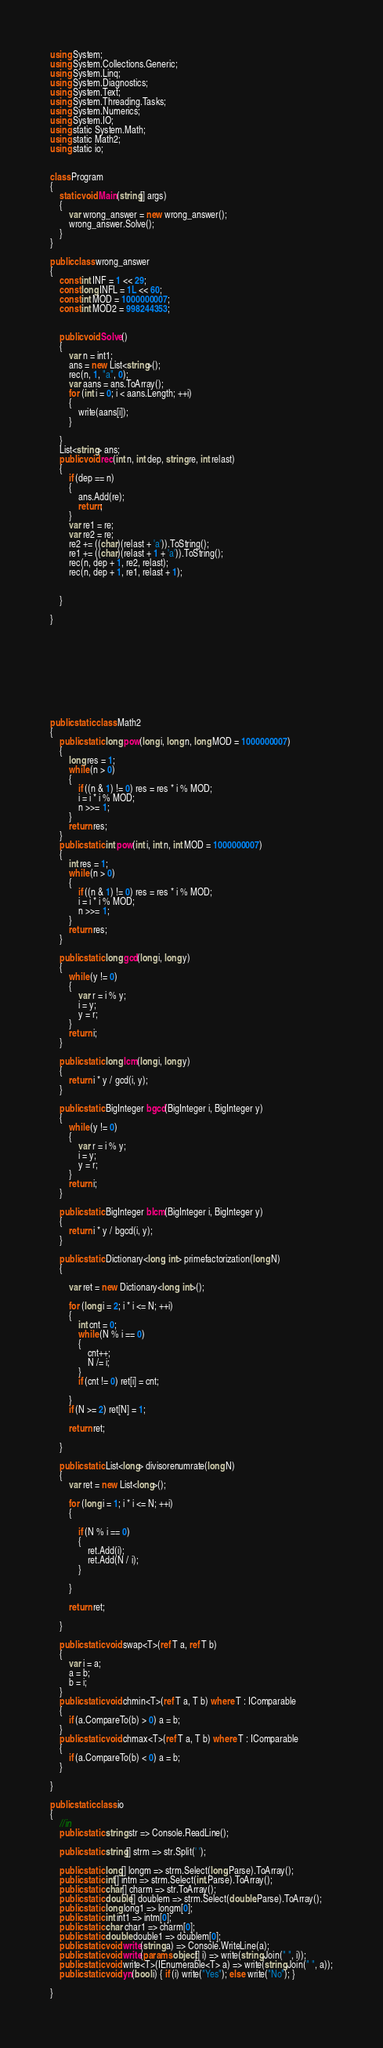Convert code to text. <code><loc_0><loc_0><loc_500><loc_500><_C#_>using System;
using System.Collections.Generic;
using System.Linq;
using System.Diagnostics;
using System.Text;
using System.Threading.Tasks;
using System.Numerics;
using System.IO;
using static System.Math;
using static Math2;
using static io;


class Program
{
    static void Main(string[] args)
    {
        var wrong_answer = new wrong_answer();
        wrong_answer.Solve();
    }
}

public class wrong_answer
{
    const int INF = 1 << 29;
    const long INFL = 1L << 60;
    const int MOD = 1000000007;
    const int MOD2 = 998244353;


    public void Solve()
    {
        var n = int1;
        ans = new List<string>();
        rec(n, 1, "a", 0);
        var aans = ans.ToArray();
        for (int i = 0; i < aans.Length; ++i)
        {
            write(aans[i]);
        }

    }
    List<string> ans;
    public void rec(int n, int dep, string re, int relast)
    {
        if (dep == n)
        {
            ans.Add(re);
            return;
        }
        var re1 = re;
        var re2 = re;
        re2 += ((char)(relast + 'a')).ToString();
        re1 += ((char)(relast + 1 + 'a')).ToString();
        rec(n, dep + 1, re2, relast);
        rec(n, dep + 1, re1, relast + 1);


    }

}










public static class Math2
{
    public static long pow(long i, long n, long MOD = 1000000007)
    {
        long res = 1;
        while (n > 0)
        {
            if ((n & 1) != 0) res = res * i % MOD;
            i = i * i % MOD;
            n >>= 1;
        }
        return res;
    }
    public static int pow(int i, int n, int MOD = 1000000007)
    {
        int res = 1;
        while (n > 0)
        {
            if ((n & 1) != 0) res = res * i % MOD;
            i = i * i % MOD;
            n >>= 1;
        }
        return res;
    }

    public static long gcd(long i, long y)
    {
        while (y != 0)
        {
            var r = i % y;
            i = y;
            y = r;
        }
        return i;
    }

    public static long lcm(long i, long y)
    {
        return i * y / gcd(i, y);
    }

    public static BigInteger bgcd(BigInteger i, BigInteger y)
    {
        while (y != 0)
        {
            var r = i % y;
            i = y;
            y = r;
        }
        return i;
    }

    public static BigInteger blcm(BigInteger i, BigInteger y)
    {
        return i * y / bgcd(i, y);
    }

    public static Dictionary<long, int> primefactorization(long N)
    {

        var ret = new Dictionary<long, int>();

        for (long i = 2; i * i <= N; ++i)
        {
            int cnt = 0;
            while (N % i == 0)
            {
                cnt++;
                N /= i;
            }
            if (cnt != 0) ret[i] = cnt;

        }
        if (N >= 2) ret[N] = 1;

        return ret;

    }

    public static List<long> divisorenumrate(long N)
    {
        var ret = new List<long>();

        for (long i = 1; i * i <= N; ++i)
        {

            if (N % i == 0)
            {
                ret.Add(i);
                ret.Add(N / i);
            }

        }

        return ret;

    }

    public static void swap<T>(ref T a, ref T b)
    {
        var i = a;
        a = b;
        b = i;
    }
    public static void chmin<T>(ref T a, T b) where T : IComparable
    {
        if (a.CompareTo(b) > 0) a = b;
    }
    public static void chmax<T>(ref T a, T b) where T : IComparable
    {
        if (a.CompareTo(b) < 0) a = b;
    }

}

public static class io
{
    //in
    public static string str => Console.ReadLine();

    public static string[] strm => str.Split(' ');

    public static long[] longm => strm.Select(long.Parse).ToArray();
    public static int[] intm => strm.Select(int.Parse).ToArray();
    public static char[] charm => str.ToArray();
    public static double[] doublem => strm.Select(double.Parse).ToArray();
    public static long long1 => longm[0];
    public static int int1 => intm[0];
    public static char char1 => charm[0];
    public static double double1 => doublem[0];
    public static void write(string a) => Console.WriteLine(a);
    public static void write(params object[] i) => write(string.Join(" ", i));
    public static void write<T>(IEnumerable<T> a) => write(string.Join(" ", a));
    public static void yn(bool i) { if (i) write("Yes"); else write("No"); }

}
</code> 